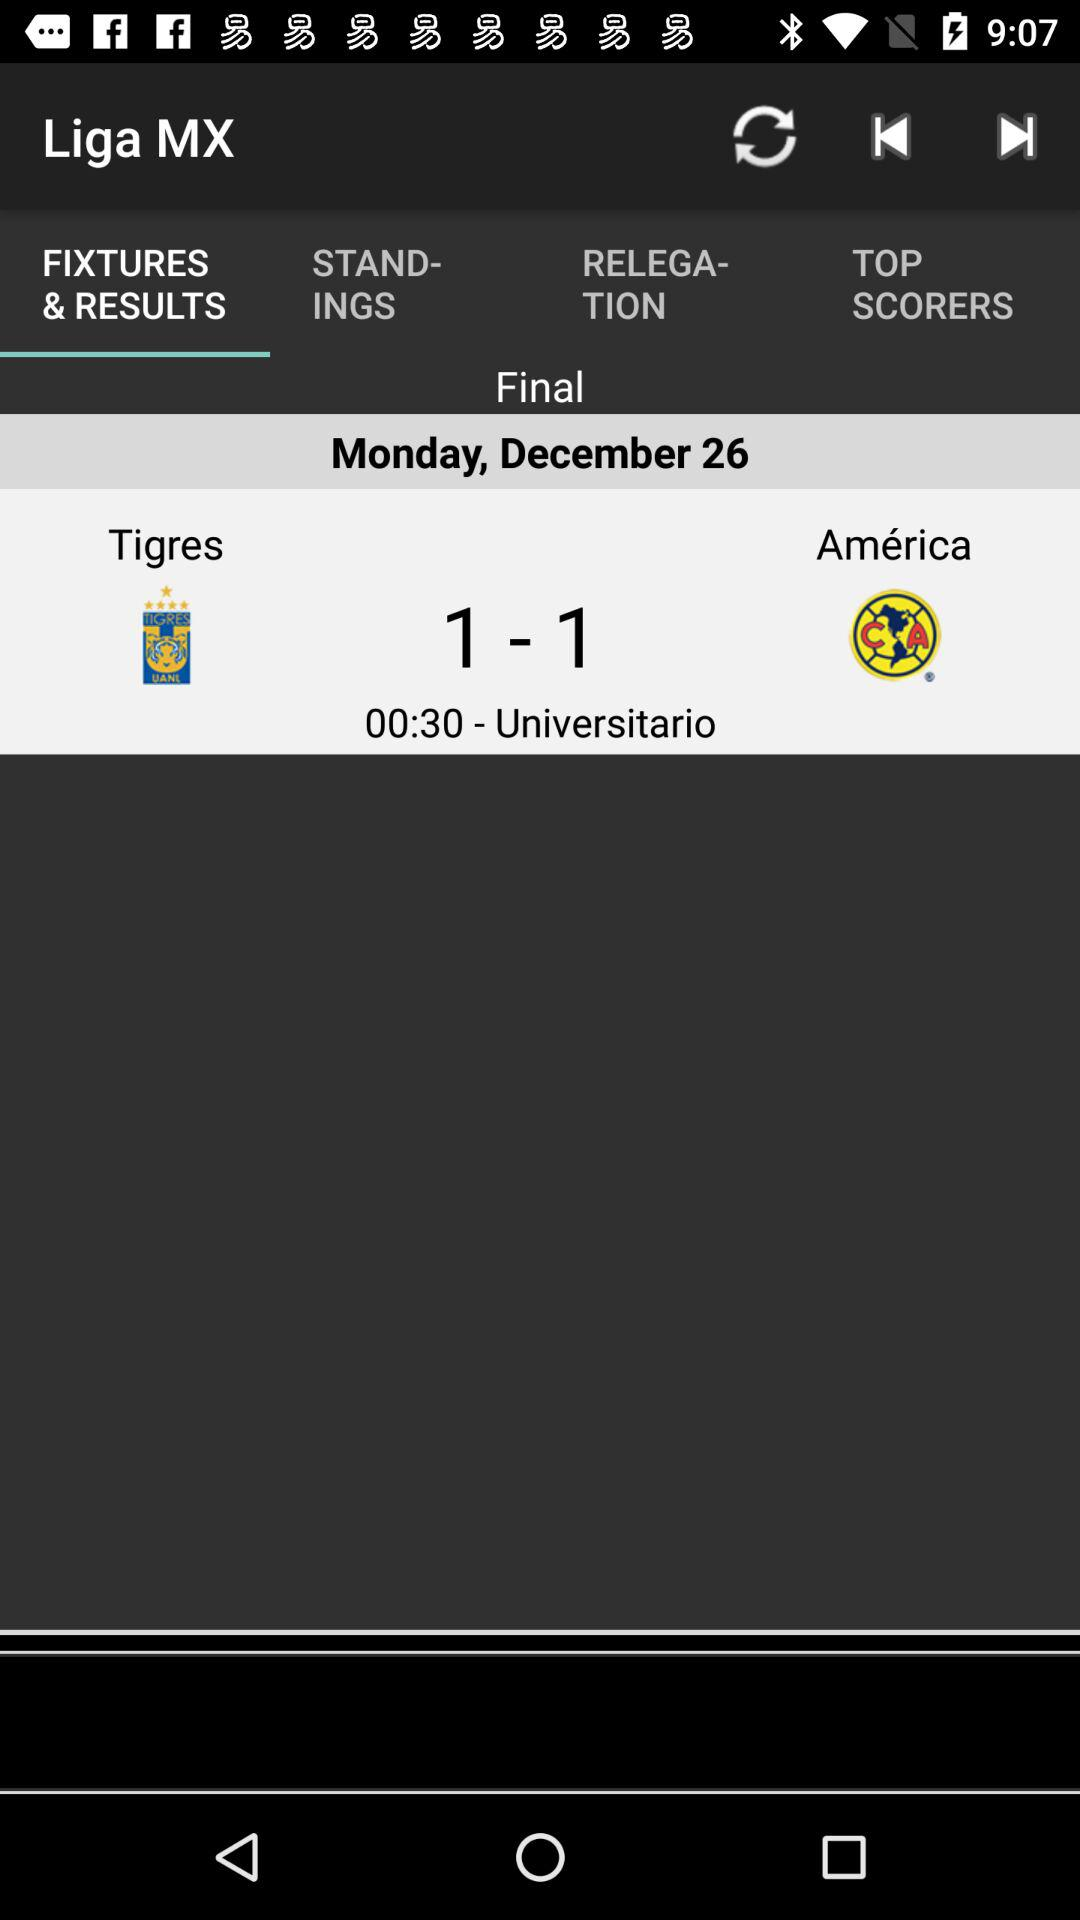What is the result of final match?
When the provided information is insufficient, respond with <no answer>. <no answer> 